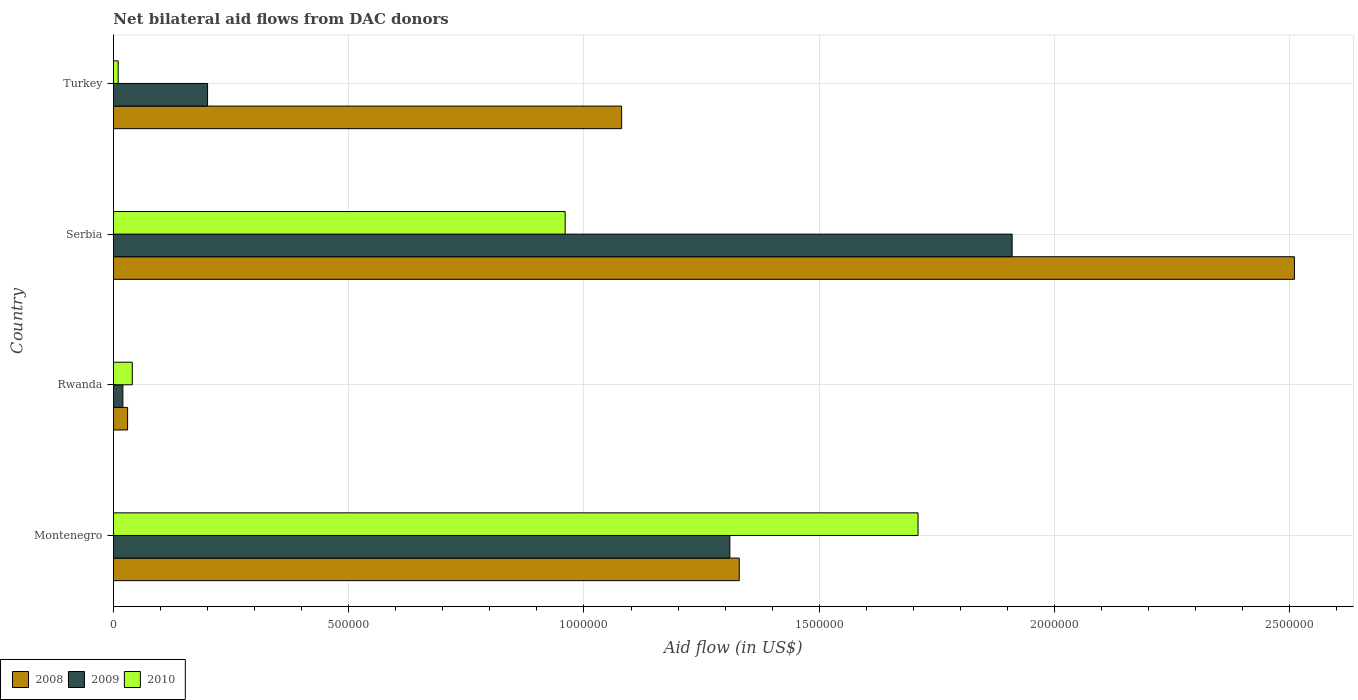Are the number of bars on each tick of the Y-axis equal?
Offer a very short reply. Yes. How many bars are there on the 1st tick from the bottom?
Keep it short and to the point. 3. What is the label of the 2nd group of bars from the top?
Provide a succinct answer. Serbia. In how many cases, is the number of bars for a given country not equal to the number of legend labels?
Provide a short and direct response. 0. What is the net bilateral aid flow in 2009 in Turkey?
Ensure brevity in your answer.  2.00e+05. Across all countries, what is the maximum net bilateral aid flow in 2010?
Ensure brevity in your answer.  1.71e+06. Across all countries, what is the minimum net bilateral aid flow in 2010?
Your answer should be compact. 10000. In which country was the net bilateral aid flow in 2009 maximum?
Keep it short and to the point. Serbia. In which country was the net bilateral aid flow in 2008 minimum?
Give a very brief answer. Rwanda. What is the total net bilateral aid flow in 2008 in the graph?
Your answer should be compact. 4.95e+06. What is the difference between the net bilateral aid flow in 2010 in Montenegro and that in Serbia?
Keep it short and to the point. 7.50e+05. What is the difference between the net bilateral aid flow in 2009 in Serbia and the net bilateral aid flow in 2008 in Turkey?
Offer a terse response. 8.30e+05. What is the average net bilateral aid flow in 2009 per country?
Give a very brief answer. 8.60e+05. In how many countries, is the net bilateral aid flow in 2008 greater than 200000 US$?
Your answer should be very brief. 3. What is the ratio of the net bilateral aid flow in 2010 in Rwanda to that in Turkey?
Provide a succinct answer. 4. Is the net bilateral aid flow in 2010 in Rwanda less than that in Turkey?
Give a very brief answer. No. Is the difference between the net bilateral aid flow in 2009 in Montenegro and Serbia greater than the difference between the net bilateral aid flow in 2008 in Montenegro and Serbia?
Offer a terse response. Yes. What is the difference between the highest and the second highest net bilateral aid flow in 2010?
Your answer should be very brief. 7.50e+05. What is the difference between the highest and the lowest net bilateral aid flow in 2010?
Offer a terse response. 1.70e+06. Is the sum of the net bilateral aid flow in 2008 in Montenegro and Rwanda greater than the maximum net bilateral aid flow in 2010 across all countries?
Your answer should be compact. No. What does the 1st bar from the bottom in Serbia represents?
Offer a terse response. 2008. Is it the case that in every country, the sum of the net bilateral aid flow in 2009 and net bilateral aid flow in 2008 is greater than the net bilateral aid flow in 2010?
Offer a terse response. Yes. How many bars are there?
Keep it short and to the point. 12. How many countries are there in the graph?
Offer a terse response. 4. Does the graph contain any zero values?
Provide a succinct answer. No. How many legend labels are there?
Your answer should be compact. 3. How are the legend labels stacked?
Offer a terse response. Horizontal. What is the title of the graph?
Ensure brevity in your answer.  Net bilateral aid flows from DAC donors. Does "1993" appear as one of the legend labels in the graph?
Ensure brevity in your answer.  No. What is the label or title of the X-axis?
Make the answer very short. Aid flow (in US$). What is the label or title of the Y-axis?
Your answer should be compact. Country. What is the Aid flow (in US$) of 2008 in Montenegro?
Give a very brief answer. 1.33e+06. What is the Aid flow (in US$) of 2009 in Montenegro?
Your answer should be compact. 1.31e+06. What is the Aid flow (in US$) in 2010 in Montenegro?
Provide a short and direct response. 1.71e+06. What is the Aid flow (in US$) of 2008 in Rwanda?
Your answer should be very brief. 3.00e+04. What is the Aid flow (in US$) of 2009 in Rwanda?
Provide a short and direct response. 2.00e+04. What is the Aid flow (in US$) of 2008 in Serbia?
Make the answer very short. 2.51e+06. What is the Aid flow (in US$) in 2009 in Serbia?
Your answer should be very brief. 1.91e+06. What is the Aid flow (in US$) in 2010 in Serbia?
Your response must be concise. 9.60e+05. What is the Aid flow (in US$) of 2008 in Turkey?
Your answer should be compact. 1.08e+06. Across all countries, what is the maximum Aid flow (in US$) in 2008?
Make the answer very short. 2.51e+06. Across all countries, what is the maximum Aid flow (in US$) of 2009?
Make the answer very short. 1.91e+06. Across all countries, what is the maximum Aid flow (in US$) in 2010?
Keep it short and to the point. 1.71e+06. Across all countries, what is the minimum Aid flow (in US$) of 2008?
Your answer should be very brief. 3.00e+04. Across all countries, what is the minimum Aid flow (in US$) of 2009?
Offer a terse response. 2.00e+04. Across all countries, what is the minimum Aid flow (in US$) of 2010?
Provide a short and direct response. 10000. What is the total Aid flow (in US$) in 2008 in the graph?
Ensure brevity in your answer.  4.95e+06. What is the total Aid flow (in US$) in 2009 in the graph?
Provide a short and direct response. 3.44e+06. What is the total Aid flow (in US$) in 2010 in the graph?
Give a very brief answer. 2.72e+06. What is the difference between the Aid flow (in US$) of 2008 in Montenegro and that in Rwanda?
Your response must be concise. 1.30e+06. What is the difference between the Aid flow (in US$) of 2009 in Montenegro and that in Rwanda?
Give a very brief answer. 1.29e+06. What is the difference between the Aid flow (in US$) in 2010 in Montenegro and that in Rwanda?
Your answer should be compact. 1.67e+06. What is the difference between the Aid flow (in US$) in 2008 in Montenegro and that in Serbia?
Offer a very short reply. -1.18e+06. What is the difference between the Aid flow (in US$) in 2009 in Montenegro and that in Serbia?
Provide a succinct answer. -6.00e+05. What is the difference between the Aid flow (in US$) of 2010 in Montenegro and that in Serbia?
Give a very brief answer. 7.50e+05. What is the difference between the Aid flow (in US$) in 2009 in Montenegro and that in Turkey?
Your answer should be compact. 1.11e+06. What is the difference between the Aid flow (in US$) in 2010 in Montenegro and that in Turkey?
Make the answer very short. 1.70e+06. What is the difference between the Aid flow (in US$) in 2008 in Rwanda and that in Serbia?
Offer a very short reply. -2.48e+06. What is the difference between the Aid flow (in US$) of 2009 in Rwanda and that in Serbia?
Offer a terse response. -1.89e+06. What is the difference between the Aid flow (in US$) of 2010 in Rwanda and that in Serbia?
Offer a very short reply. -9.20e+05. What is the difference between the Aid flow (in US$) of 2008 in Rwanda and that in Turkey?
Give a very brief answer. -1.05e+06. What is the difference between the Aid flow (in US$) in 2008 in Serbia and that in Turkey?
Keep it short and to the point. 1.43e+06. What is the difference between the Aid flow (in US$) of 2009 in Serbia and that in Turkey?
Offer a very short reply. 1.71e+06. What is the difference between the Aid flow (in US$) of 2010 in Serbia and that in Turkey?
Your answer should be compact. 9.50e+05. What is the difference between the Aid flow (in US$) in 2008 in Montenegro and the Aid flow (in US$) in 2009 in Rwanda?
Your answer should be very brief. 1.31e+06. What is the difference between the Aid flow (in US$) in 2008 in Montenegro and the Aid flow (in US$) in 2010 in Rwanda?
Make the answer very short. 1.29e+06. What is the difference between the Aid flow (in US$) of 2009 in Montenegro and the Aid flow (in US$) of 2010 in Rwanda?
Give a very brief answer. 1.27e+06. What is the difference between the Aid flow (in US$) in 2008 in Montenegro and the Aid flow (in US$) in 2009 in Serbia?
Offer a very short reply. -5.80e+05. What is the difference between the Aid flow (in US$) in 2008 in Montenegro and the Aid flow (in US$) in 2010 in Serbia?
Ensure brevity in your answer.  3.70e+05. What is the difference between the Aid flow (in US$) of 2008 in Montenegro and the Aid flow (in US$) of 2009 in Turkey?
Provide a short and direct response. 1.13e+06. What is the difference between the Aid flow (in US$) of 2008 in Montenegro and the Aid flow (in US$) of 2010 in Turkey?
Keep it short and to the point. 1.32e+06. What is the difference between the Aid flow (in US$) in 2009 in Montenegro and the Aid flow (in US$) in 2010 in Turkey?
Provide a short and direct response. 1.30e+06. What is the difference between the Aid flow (in US$) of 2008 in Rwanda and the Aid flow (in US$) of 2009 in Serbia?
Make the answer very short. -1.88e+06. What is the difference between the Aid flow (in US$) of 2008 in Rwanda and the Aid flow (in US$) of 2010 in Serbia?
Offer a very short reply. -9.30e+05. What is the difference between the Aid flow (in US$) of 2009 in Rwanda and the Aid flow (in US$) of 2010 in Serbia?
Give a very brief answer. -9.40e+05. What is the difference between the Aid flow (in US$) of 2008 in Rwanda and the Aid flow (in US$) of 2009 in Turkey?
Provide a short and direct response. -1.70e+05. What is the difference between the Aid flow (in US$) in 2008 in Rwanda and the Aid flow (in US$) in 2010 in Turkey?
Offer a terse response. 2.00e+04. What is the difference between the Aid flow (in US$) of 2009 in Rwanda and the Aid flow (in US$) of 2010 in Turkey?
Offer a terse response. 10000. What is the difference between the Aid flow (in US$) in 2008 in Serbia and the Aid flow (in US$) in 2009 in Turkey?
Your answer should be compact. 2.31e+06. What is the difference between the Aid flow (in US$) in 2008 in Serbia and the Aid flow (in US$) in 2010 in Turkey?
Your answer should be very brief. 2.50e+06. What is the difference between the Aid flow (in US$) in 2009 in Serbia and the Aid flow (in US$) in 2010 in Turkey?
Offer a terse response. 1.90e+06. What is the average Aid flow (in US$) of 2008 per country?
Your response must be concise. 1.24e+06. What is the average Aid flow (in US$) of 2009 per country?
Ensure brevity in your answer.  8.60e+05. What is the average Aid flow (in US$) of 2010 per country?
Offer a terse response. 6.80e+05. What is the difference between the Aid flow (in US$) in 2008 and Aid flow (in US$) in 2009 in Montenegro?
Your answer should be compact. 2.00e+04. What is the difference between the Aid flow (in US$) in 2008 and Aid flow (in US$) in 2010 in Montenegro?
Provide a short and direct response. -3.80e+05. What is the difference between the Aid flow (in US$) in 2009 and Aid flow (in US$) in 2010 in Montenegro?
Provide a succinct answer. -4.00e+05. What is the difference between the Aid flow (in US$) of 2008 and Aid flow (in US$) of 2009 in Rwanda?
Make the answer very short. 10000. What is the difference between the Aid flow (in US$) in 2008 and Aid flow (in US$) in 2010 in Rwanda?
Your answer should be very brief. -10000. What is the difference between the Aid flow (in US$) in 2008 and Aid flow (in US$) in 2009 in Serbia?
Ensure brevity in your answer.  6.00e+05. What is the difference between the Aid flow (in US$) of 2008 and Aid flow (in US$) of 2010 in Serbia?
Provide a short and direct response. 1.55e+06. What is the difference between the Aid flow (in US$) of 2009 and Aid flow (in US$) of 2010 in Serbia?
Your response must be concise. 9.50e+05. What is the difference between the Aid flow (in US$) in 2008 and Aid flow (in US$) in 2009 in Turkey?
Make the answer very short. 8.80e+05. What is the difference between the Aid flow (in US$) in 2008 and Aid flow (in US$) in 2010 in Turkey?
Make the answer very short. 1.07e+06. What is the ratio of the Aid flow (in US$) in 2008 in Montenegro to that in Rwanda?
Ensure brevity in your answer.  44.33. What is the ratio of the Aid flow (in US$) of 2009 in Montenegro to that in Rwanda?
Offer a terse response. 65.5. What is the ratio of the Aid flow (in US$) of 2010 in Montenegro to that in Rwanda?
Make the answer very short. 42.75. What is the ratio of the Aid flow (in US$) of 2008 in Montenegro to that in Serbia?
Ensure brevity in your answer.  0.53. What is the ratio of the Aid flow (in US$) in 2009 in Montenegro to that in Serbia?
Provide a succinct answer. 0.69. What is the ratio of the Aid flow (in US$) in 2010 in Montenegro to that in Serbia?
Provide a succinct answer. 1.78. What is the ratio of the Aid flow (in US$) of 2008 in Montenegro to that in Turkey?
Make the answer very short. 1.23. What is the ratio of the Aid flow (in US$) of 2009 in Montenegro to that in Turkey?
Your answer should be very brief. 6.55. What is the ratio of the Aid flow (in US$) in 2010 in Montenegro to that in Turkey?
Offer a terse response. 171. What is the ratio of the Aid flow (in US$) in 2008 in Rwanda to that in Serbia?
Your response must be concise. 0.01. What is the ratio of the Aid flow (in US$) in 2009 in Rwanda to that in Serbia?
Your answer should be compact. 0.01. What is the ratio of the Aid flow (in US$) in 2010 in Rwanda to that in Serbia?
Keep it short and to the point. 0.04. What is the ratio of the Aid flow (in US$) in 2008 in Rwanda to that in Turkey?
Offer a terse response. 0.03. What is the ratio of the Aid flow (in US$) of 2010 in Rwanda to that in Turkey?
Your answer should be very brief. 4. What is the ratio of the Aid flow (in US$) of 2008 in Serbia to that in Turkey?
Keep it short and to the point. 2.32. What is the ratio of the Aid flow (in US$) in 2009 in Serbia to that in Turkey?
Your answer should be compact. 9.55. What is the ratio of the Aid flow (in US$) in 2010 in Serbia to that in Turkey?
Give a very brief answer. 96. What is the difference between the highest and the second highest Aid flow (in US$) of 2008?
Give a very brief answer. 1.18e+06. What is the difference between the highest and the second highest Aid flow (in US$) of 2009?
Your response must be concise. 6.00e+05. What is the difference between the highest and the second highest Aid flow (in US$) in 2010?
Keep it short and to the point. 7.50e+05. What is the difference between the highest and the lowest Aid flow (in US$) in 2008?
Your answer should be very brief. 2.48e+06. What is the difference between the highest and the lowest Aid flow (in US$) of 2009?
Keep it short and to the point. 1.89e+06. What is the difference between the highest and the lowest Aid flow (in US$) of 2010?
Offer a terse response. 1.70e+06. 